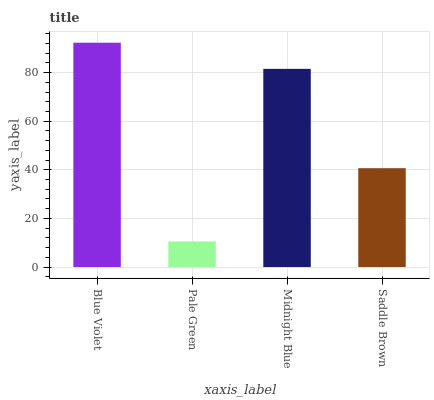Is Pale Green the minimum?
Answer yes or no. Yes. Is Blue Violet the maximum?
Answer yes or no. Yes. Is Midnight Blue the minimum?
Answer yes or no. No. Is Midnight Blue the maximum?
Answer yes or no. No. Is Midnight Blue greater than Pale Green?
Answer yes or no. Yes. Is Pale Green less than Midnight Blue?
Answer yes or no. Yes. Is Pale Green greater than Midnight Blue?
Answer yes or no. No. Is Midnight Blue less than Pale Green?
Answer yes or no. No. Is Midnight Blue the high median?
Answer yes or no. Yes. Is Saddle Brown the low median?
Answer yes or no. Yes. Is Pale Green the high median?
Answer yes or no. No. Is Pale Green the low median?
Answer yes or no. No. 